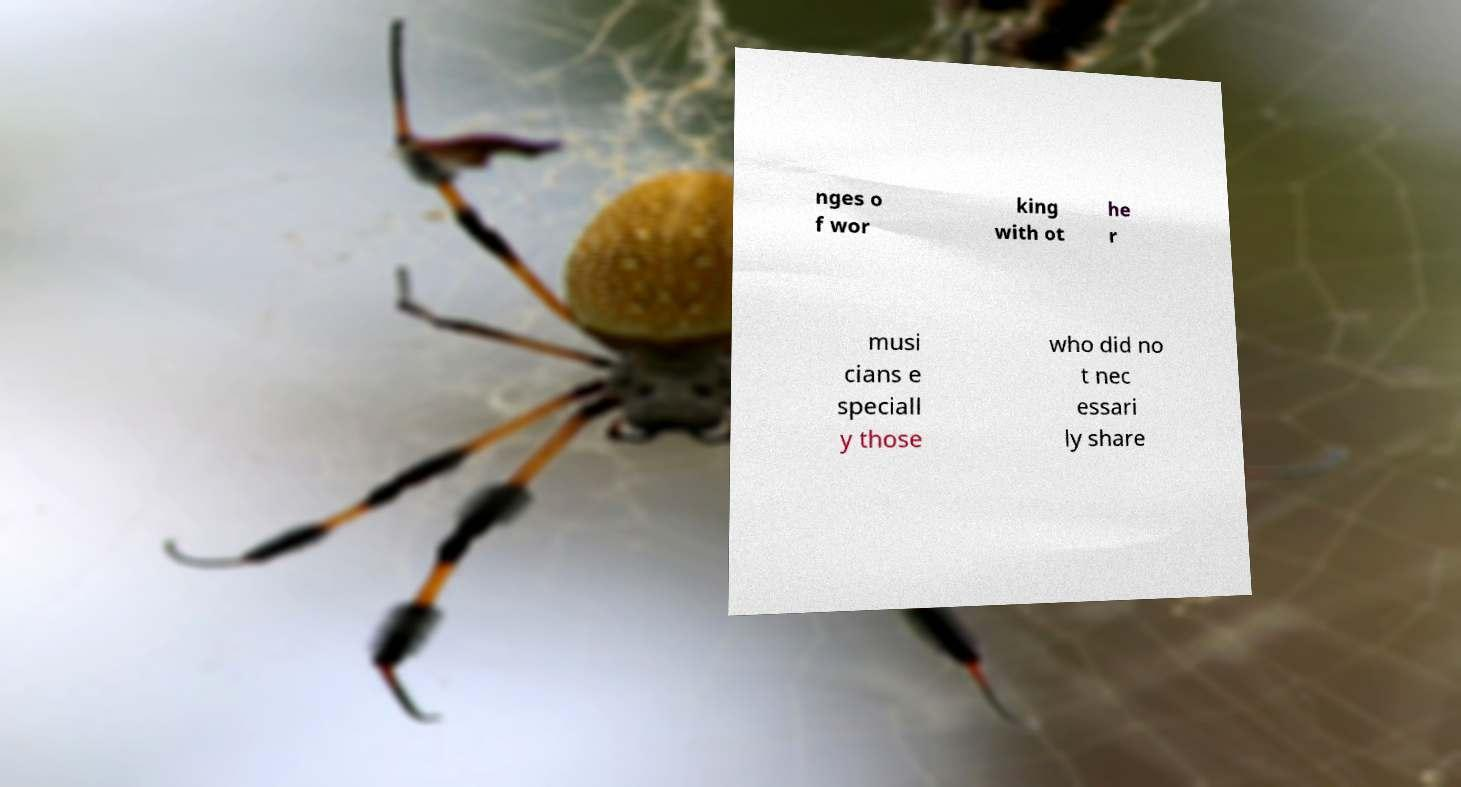I need the written content from this picture converted into text. Can you do that? nges o f wor king with ot he r musi cians e speciall y those who did no t nec essari ly share 